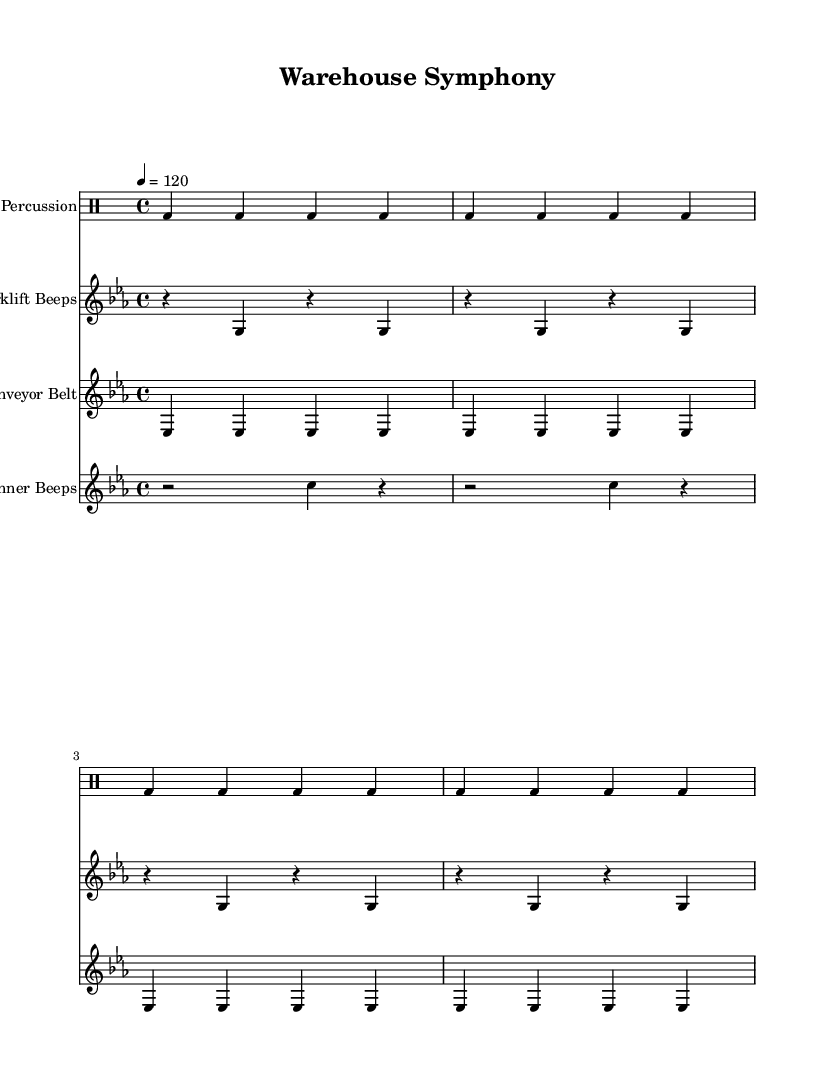What is the key signature of this music? The key signature is C minor, which has three flats (B♭, E♭, A♭). It is indicated at the beginning of the staff with the relevant flats shown.
Answer: C minor What is the time signature of this music? The time signature is 4/4, which indicates that there are four beats in each measure and the quarter note receives one beat. This is typically shown at the beginning of the score.
Answer: 4/4 What is the tempo marking of this music? The tempo marking is set to 120 beats per minute, indicated by the tempo marking that states "4 = 120". This means each beat in the ballads should be played at that speed.
Answer: 120 How many repetitions are there of the industrial percussion motif? The industrial percussion motif is repeated four times, as denoted by the "repeat unfold 4" notation at the beginning of that section.
Answer: 4 What is the specific sound being represented by the forklift beeps? The forklift beeps are represented by a series of rests and G notes, which create a rhythmic beep sound associated with forklifts. This is shown in the corresponding staff.
Answer: Beeps How is the conveyor belt rhythm characterized in this piece? The conveyor belt rhythm is characterized by a continuous sequence of E♭ notes played in quarter notes, which reflects the steady movement associated with a conveyor belt. This pattern is repeated four times.
Answer: Continuous E♭ What unique characteristic identifies the scanner beeps in this composition? The scanner beeps are identified by a combination of rests and C notes in a half note and a quarter note pattern, typical for scanning devices, displayed in the staff dedicated to scanner sounds.
Answer: Rests and C notes 